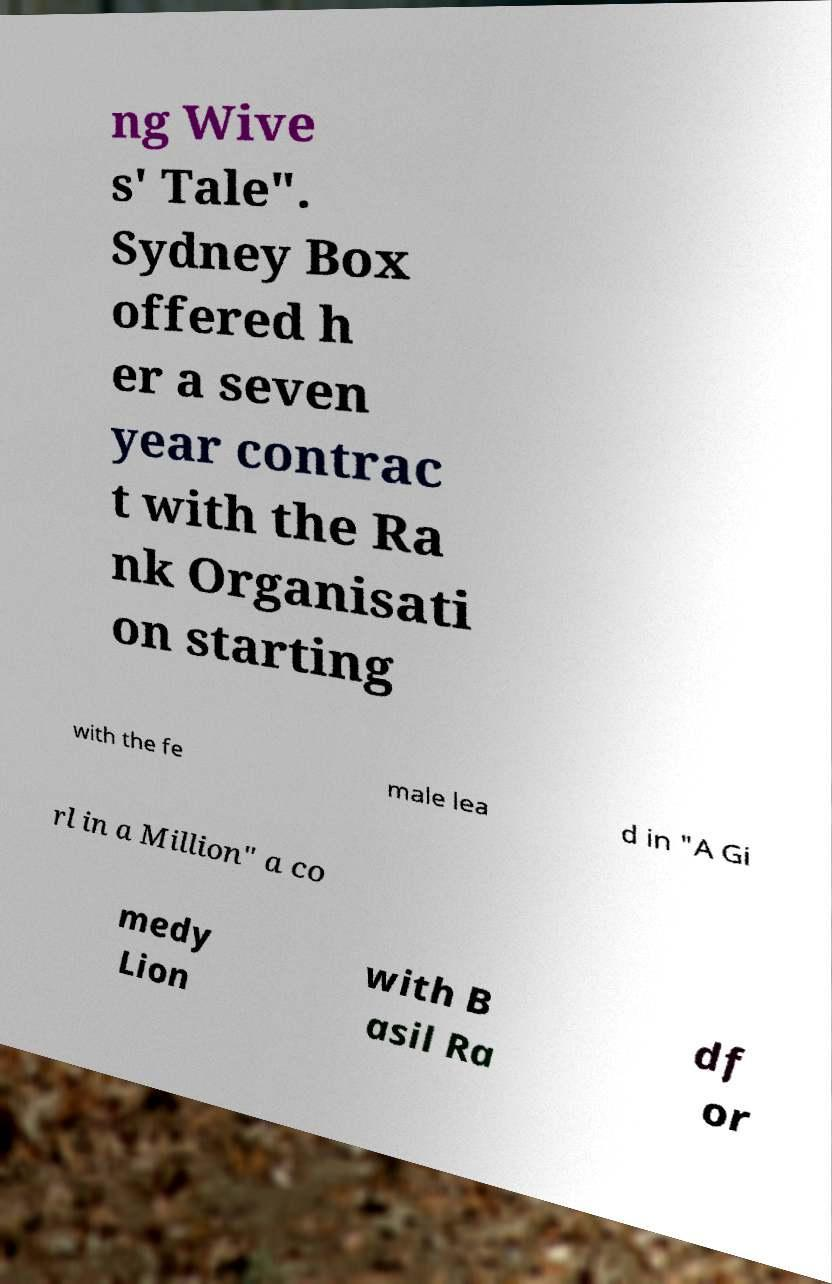Please identify and transcribe the text found in this image. ng Wive s' Tale". Sydney Box offered h er a seven year contrac t with the Ra nk Organisati on starting with the fe male lea d in "A Gi rl in a Million" a co medy Lion with B asil Ra df or 